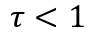<formula> <loc_0><loc_0><loc_500><loc_500>\tau < 1</formula> 